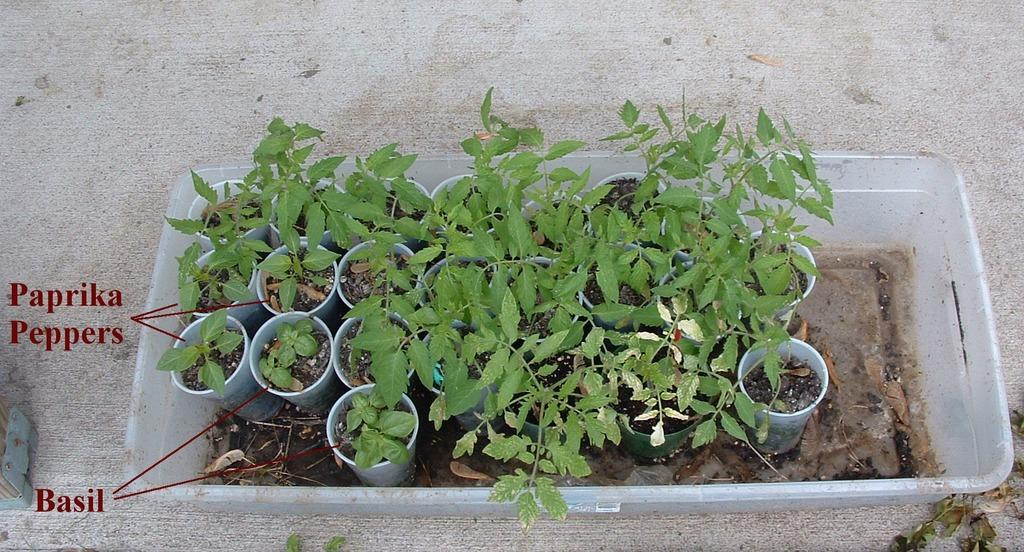What is the main object in the image? There is a box in the image. What is inside the box? The box contains pots with plants. Is there any text or writing on the image? Yes, there is text or writing on the image. How many cubs can be seen playing with the plants in the image? There are no cubs present in the image; it features a box with pots containing plants. What year does the image depict? The image does not depict a specific year; it is a still image of a box with pots containing plants. 